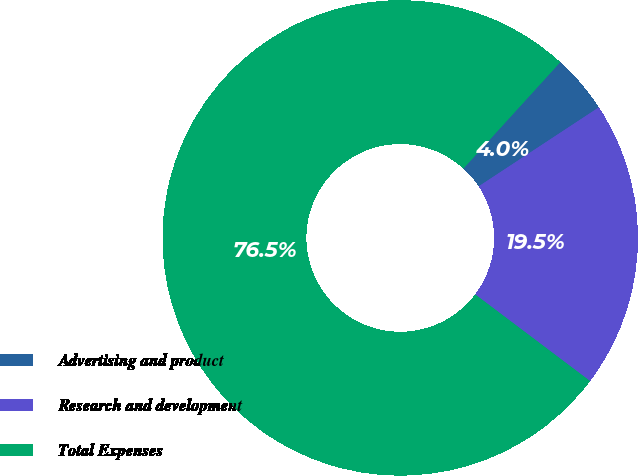Convert chart. <chart><loc_0><loc_0><loc_500><loc_500><pie_chart><fcel>Advertising and product<fcel>Research and development<fcel>Total Expenses<nl><fcel>3.99%<fcel>19.54%<fcel>76.47%<nl></chart> 